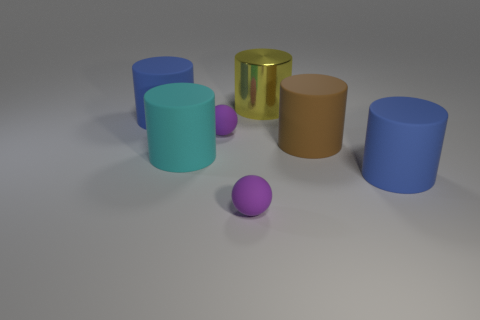How many objects are in front of the blue thing on the right side of the cyan object? There is one object, a purple sphere, located in front of a blue cylinder which is positioned to the right of the cyan cylinder. 